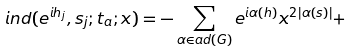Convert formula to latex. <formula><loc_0><loc_0><loc_500><loc_500>i n d ( e ^ { i h _ { j } } , s _ { j } ; t _ { a } ; x ) = - \sum _ { \alpha \in a d ( G ) } e ^ { i \alpha ( h ) } x ^ { 2 | \alpha ( s ) | } + \,</formula> 